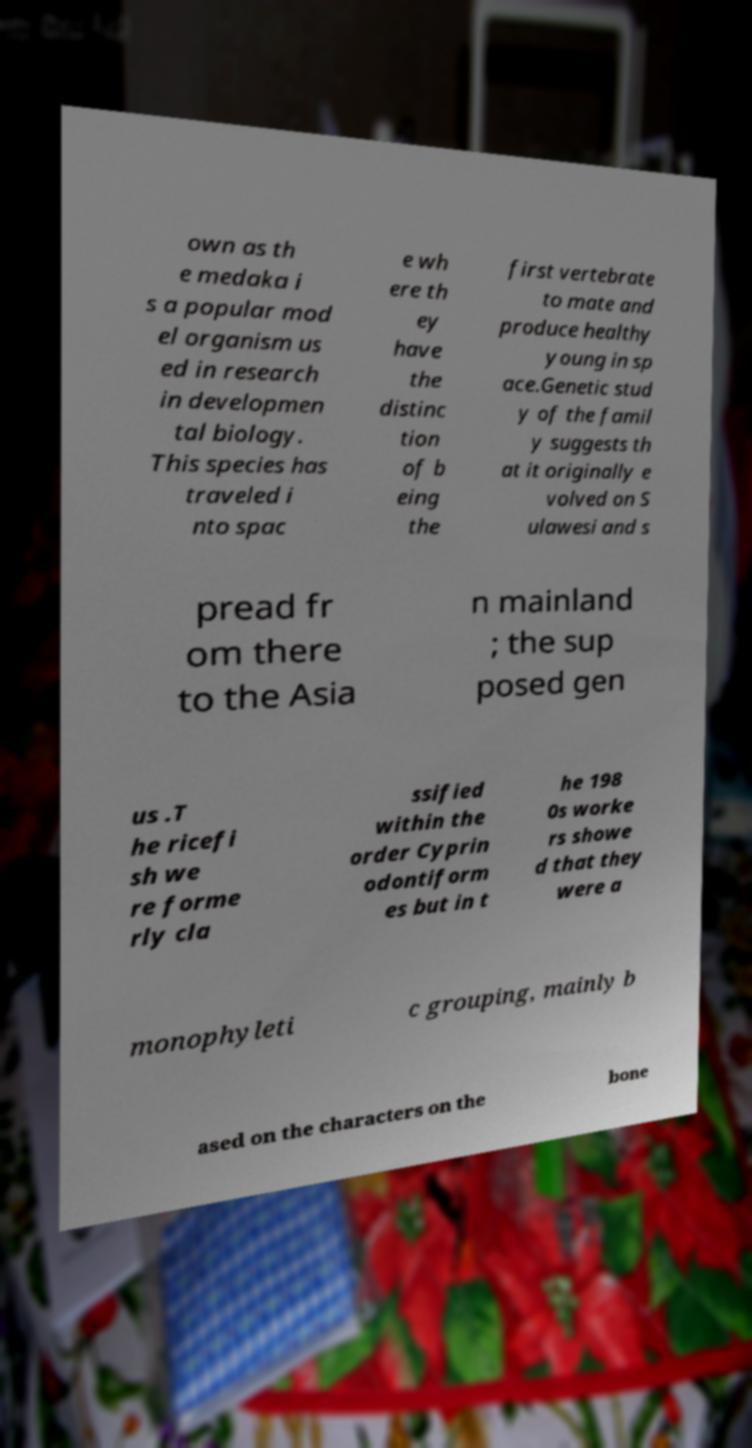I need the written content from this picture converted into text. Can you do that? own as th e medaka i s a popular mod el organism us ed in research in developmen tal biology. This species has traveled i nto spac e wh ere th ey have the distinc tion of b eing the first vertebrate to mate and produce healthy young in sp ace.Genetic stud y of the famil y suggests th at it originally e volved on S ulawesi and s pread fr om there to the Asia n mainland ; the sup posed gen us .T he ricefi sh we re forme rly cla ssified within the order Cyprin odontiform es but in t he 198 0s worke rs showe d that they were a monophyleti c grouping, mainly b ased on the characters on the bone 